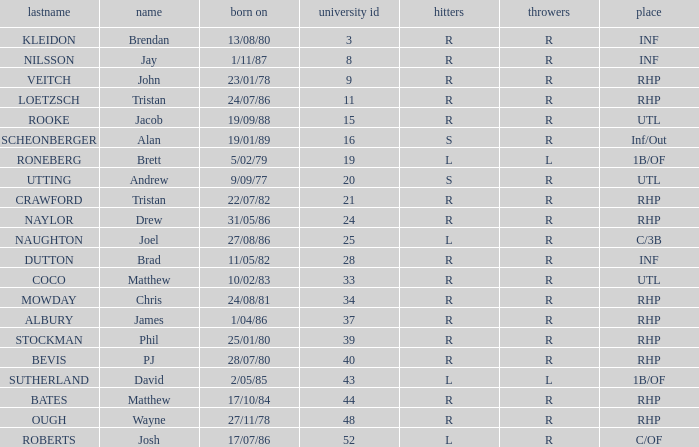Which Position has a Surname of naylor? RHP. 